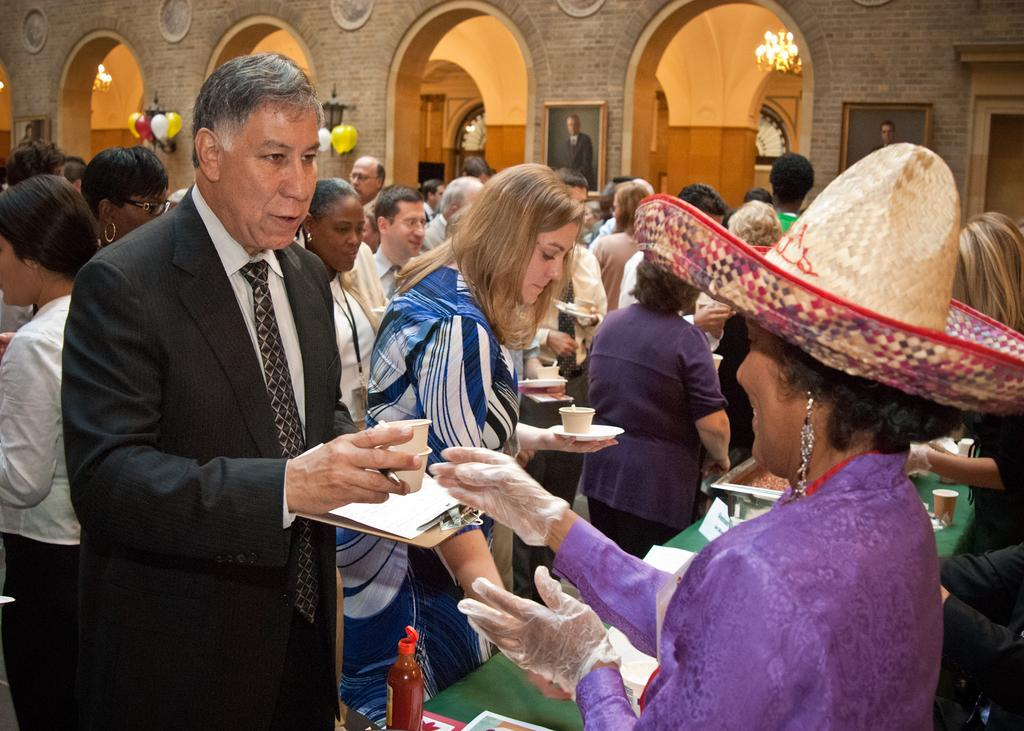Who is on the right side of the image? There is a woman on the right side of the image. What are the people in the middle of the image doing? The people are taking food cups in the middle of the image. What can be seen in the background of the image? There are balloons, lights, and photo frames on the wall in the background of the image. Reasoning: Let' Let's think step by step in order to produce the conversation. We start by identifying the main subjects and objects in the image based on the provided facts. We then formulate questions that focus on the location and characteristics of these subjects and objects, ensuring that each question can be answered definitively with the information given. We avoid yes/no questions and ensure that the language is simple and clear. Absurd Question/Answer: What type of loaf is the woman holding in the image? There is no loaf present in the image; the woman is not holding anything. Is the judge wearing a hat in the image? There is no judge or hat present in the image. What type of hat is the woman wearing in the image? There is no hat present in the image; the woman is not wearing a hat. 